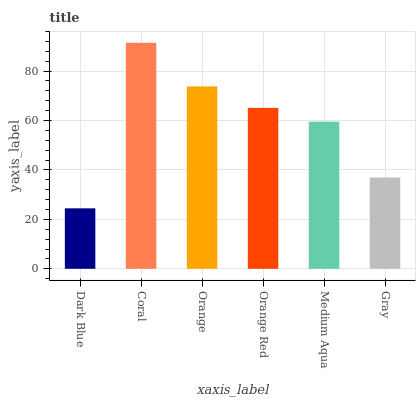Is Dark Blue the minimum?
Answer yes or no. Yes. Is Coral the maximum?
Answer yes or no. Yes. Is Orange the minimum?
Answer yes or no. No. Is Orange the maximum?
Answer yes or no. No. Is Coral greater than Orange?
Answer yes or no. Yes. Is Orange less than Coral?
Answer yes or no. Yes. Is Orange greater than Coral?
Answer yes or no. No. Is Coral less than Orange?
Answer yes or no. No. Is Orange Red the high median?
Answer yes or no. Yes. Is Medium Aqua the low median?
Answer yes or no. Yes. Is Dark Blue the high median?
Answer yes or no. No. Is Coral the low median?
Answer yes or no. No. 